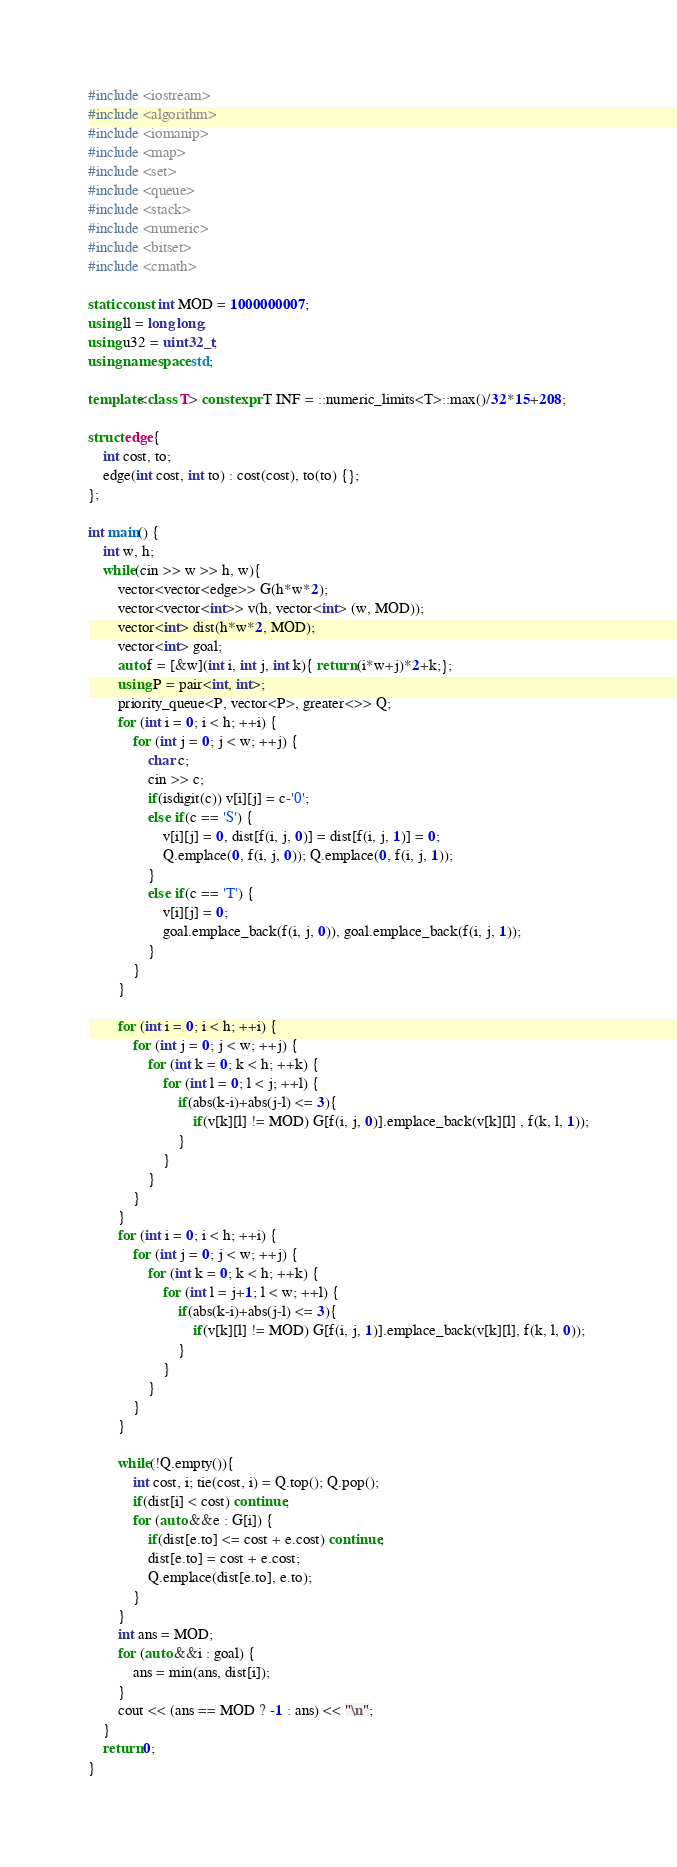Convert code to text. <code><loc_0><loc_0><loc_500><loc_500><_C++_>#include <iostream>
#include <algorithm>
#include <iomanip>
#include <map>
#include <set>
#include <queue>
#include <stack>
#include <numeric>
#include <bitset>
#include <cmath>

static const int MOD = 1000000007;
using ll = long long;
using u32 = uint32_t;
using namespace std;

template<class T> constexpr T INF = ::numeric_limits<T>::max()/32*15+208;

struct edge{
    int cost, to;
    edge(int cost, int to) : cost(cost), to(to) {};
};

int main() {
    int w, h;
    while(cin >> w >> h, w){
        vector<vector<edge>> G(h*w*2);
        vector<vector<int>> v(h, vector<int> (w, MOD));
        vector<int> dist(h*w*2, MOD);
        vector<int> goal;
        auto f = [&w](int i, int j, int k){ return (i*w+j)*2+k;};
        using P = pair<int, int>;
        priority_queue<P, vector<P>, greater<>> Q;
        for (int i = 0; i < h; ++i) {
            for (int j = 0; j < w; ++j) {
                char c;
                cin >> c;
                if(isdigit(c)) v[i][j] = c-'0';
                else if(c == 'S') {
                    v[i][j] = 0, dist[f(i, j, 0)] = dist[f(i, j, 1)] = 0;
                    Q.emplace(0, f(i, j, 0)); Q.emplace(0, f(i, j, 1));
                }
                else if(c == 'T') {
                    v[i][j] = 0;
                    goal.emplace_back(f(i, j, 0)), goal.emplace_back(f(i, j, 1));
                }
            }
        }

        for (int i = 0; i < h; ++i) {
            for (int j = 0; j < w; ++j) {
                for (int k = 0; k < h; ++k) {
                    for (int l = 0; l < j; ++l) {
                        if(abs(k-i)+abs(j-l) <= 3){
                            if(v[k][l] != MOD) G[f(i, j, 0)].emplace_back(v[k][l] , f(k, l, 1));
                        }
                    }
                }
            }
        }
        for (int i = 0; i < h; ++i) {
            for (int j = 0; j < w; ++j) {
                for (int k = 0; k < h; ++k) {
                    for (int l = j+1; l < w; ++l) {
                        if(abs(k-i)+abs(j-l) <= 3){
                            if(v[k][l] != MOD) G[f(i, j, 1)].emplace_back(v[k][l], f(k, l, 0));
                        }
                    }
                }
            }
        }

        while(!Q.empty()){
            int cost, i; tie(cost, i) = Q.top(); Q.pop();
            if(dist[i] < cost) continue;
            for (auto &&e : G[i]) {
                if(dist[e.to] <= cost + e.cost) continue;
                dist[e.to] = cost + e.cost;
                Q.emplace(dist[e.to], e.to);
            }
        }
        int ans = MOD;
        for (auto &&i : goal) {
            ans = min(ans, dist[i]);
        }
        cout << (ans == MOD ? -1 : ans) << "\n";
    }
    return 0;
}
</code> 